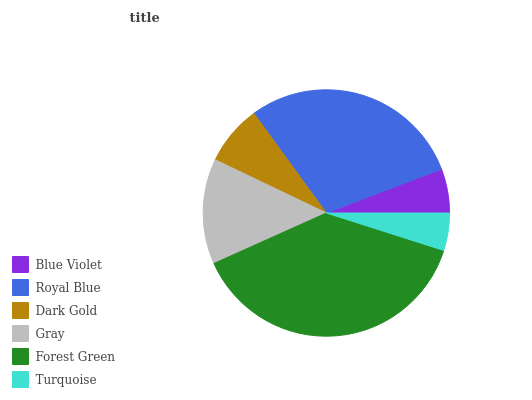Is Turquoise the minimum?
Answer yes or no. Yes. Is Forest Green the maximum?
Answer yes or no. Yes. Is Royal Blue the minimum?
Answer yes or no. No. Is Royal Blue the maximum?
Answer yes or no. No. Is Royal Blue greater than Blue Violet?
Answer yes or no. Yes. Is Blue Violet less than Royal Blue?
Answer yes or no. Yes. Is Blue Violet greater than Royal Blue?
Answer yes or no. No. Is Royal Blue less than Blue Violet?
Answer yes or no. No. Is Gray the high median?
Answer yes or no. Yes. Is Dark Gold the low median?
Answer yes or no. Yes. Is Blue Violet the high median?
Answer yes or no. No. Is Gray the low median?
Answer yes or no. No. 